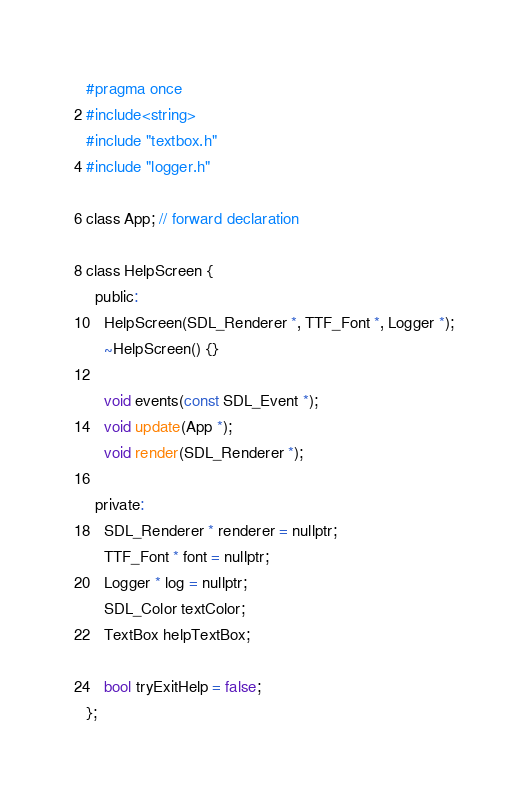Convert code to text. <code><loc_0><loc_0><loc_500><loc_500><_C_>#pragma once
#include<string>
#include "textbox.h"
#include "logger.h"

class App; // forward declaration

class HelpScreen {
  public:
    HelpScreen(SDL_Renderer *, TTF_Font *, Logger *);
    ~HelpScreen() {}

    void events(const SDL_Event *);
    void update(App *);
    void render(SDL_Renderer *);

  private:
    SDL_Renderer * renderer = nullptr;
    TTF_Font * font = nullptr;
    Logger * log = nullptr;
    SDL_Color textColor;
    TextBox helpTextBox;

    bool tryExitHelp = false;
};
</code> 